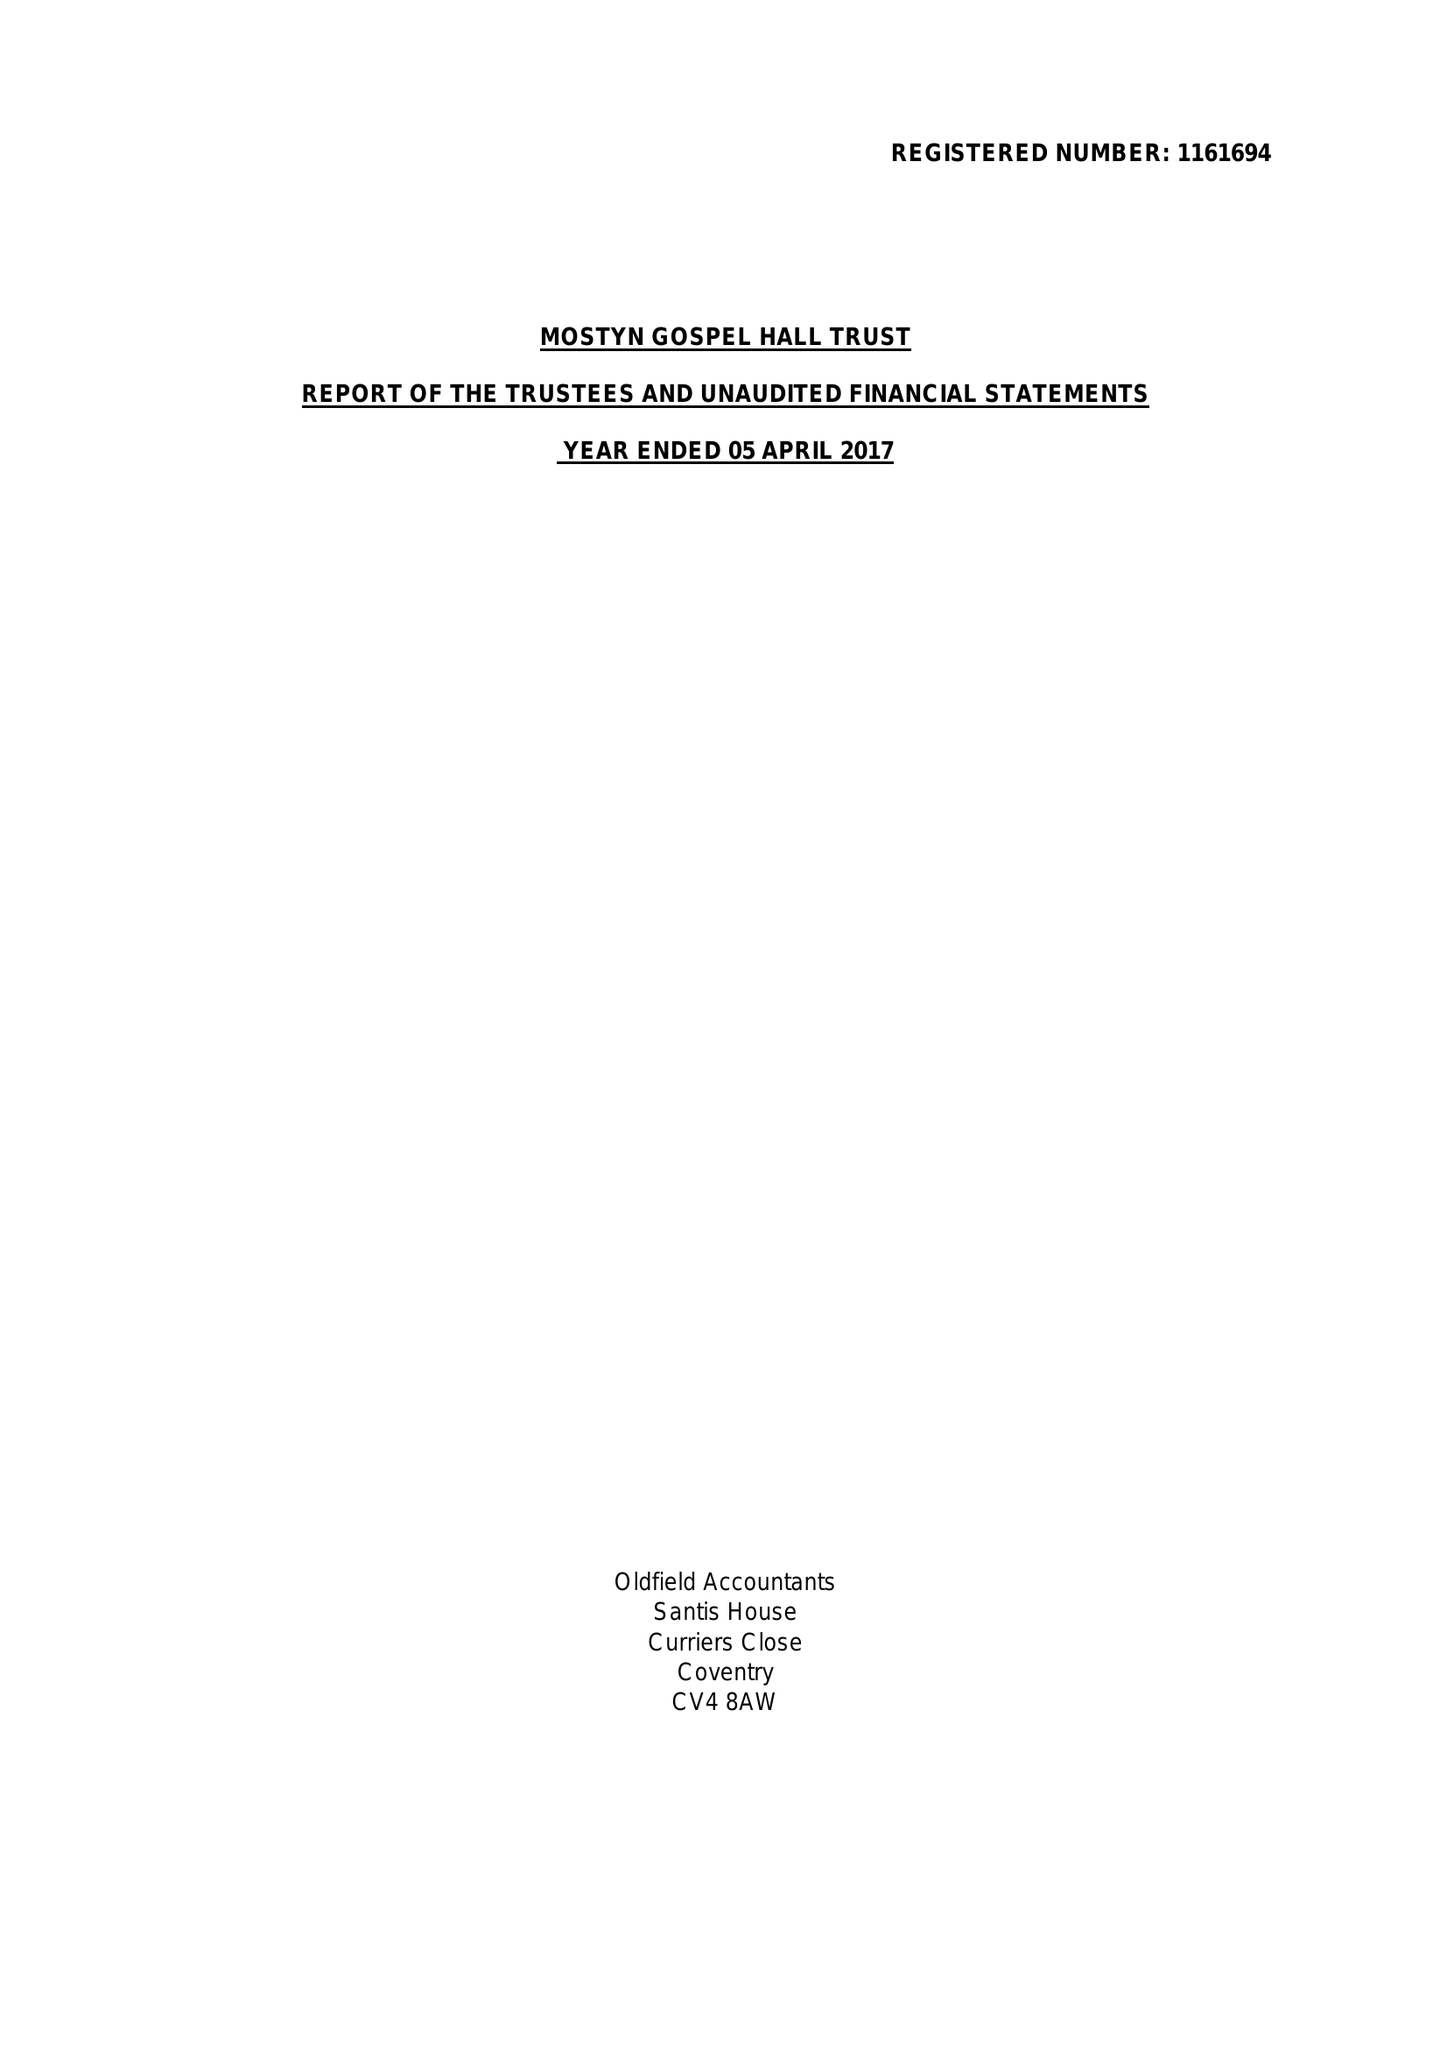What is the value for the charity_name?
Answer the question using a single word or phrase. Mostyn Gospel Hall Trust 